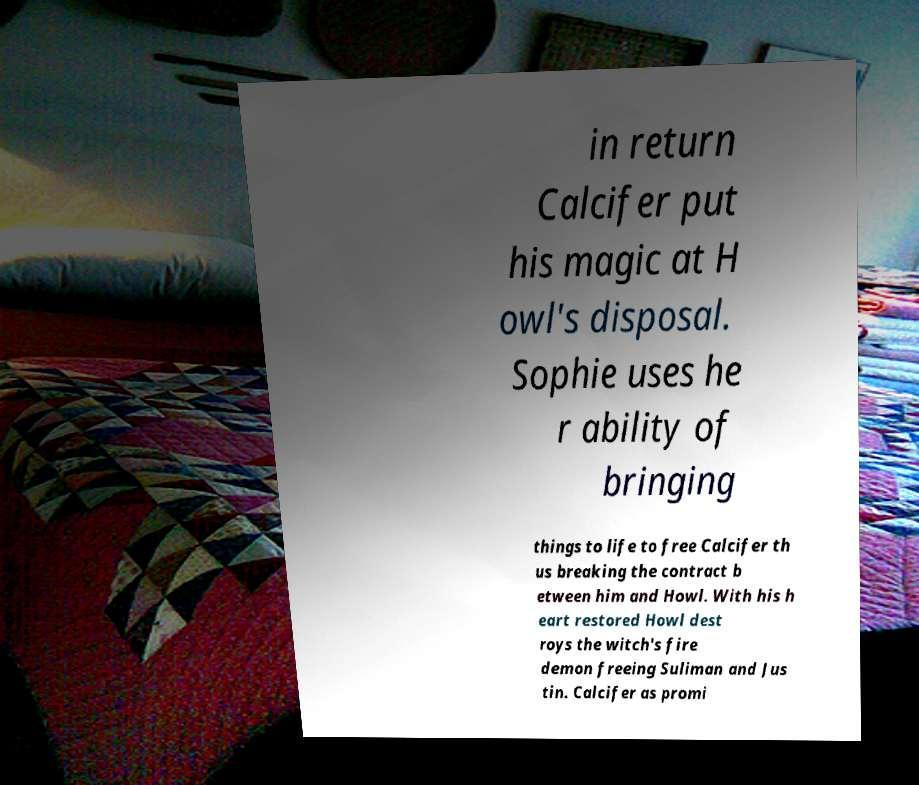Please identify and transcribe the text found in this image. in return Calcifer put his magic at H owl's disposal. Sophie uses he r ability of bringing things to life to free Calcifer th us breaking the contract b etween him and Howl. With his h eart restored Howl dest roys the witch's fire demon freeing Suliman and Jus tin. Calcifer as promi 